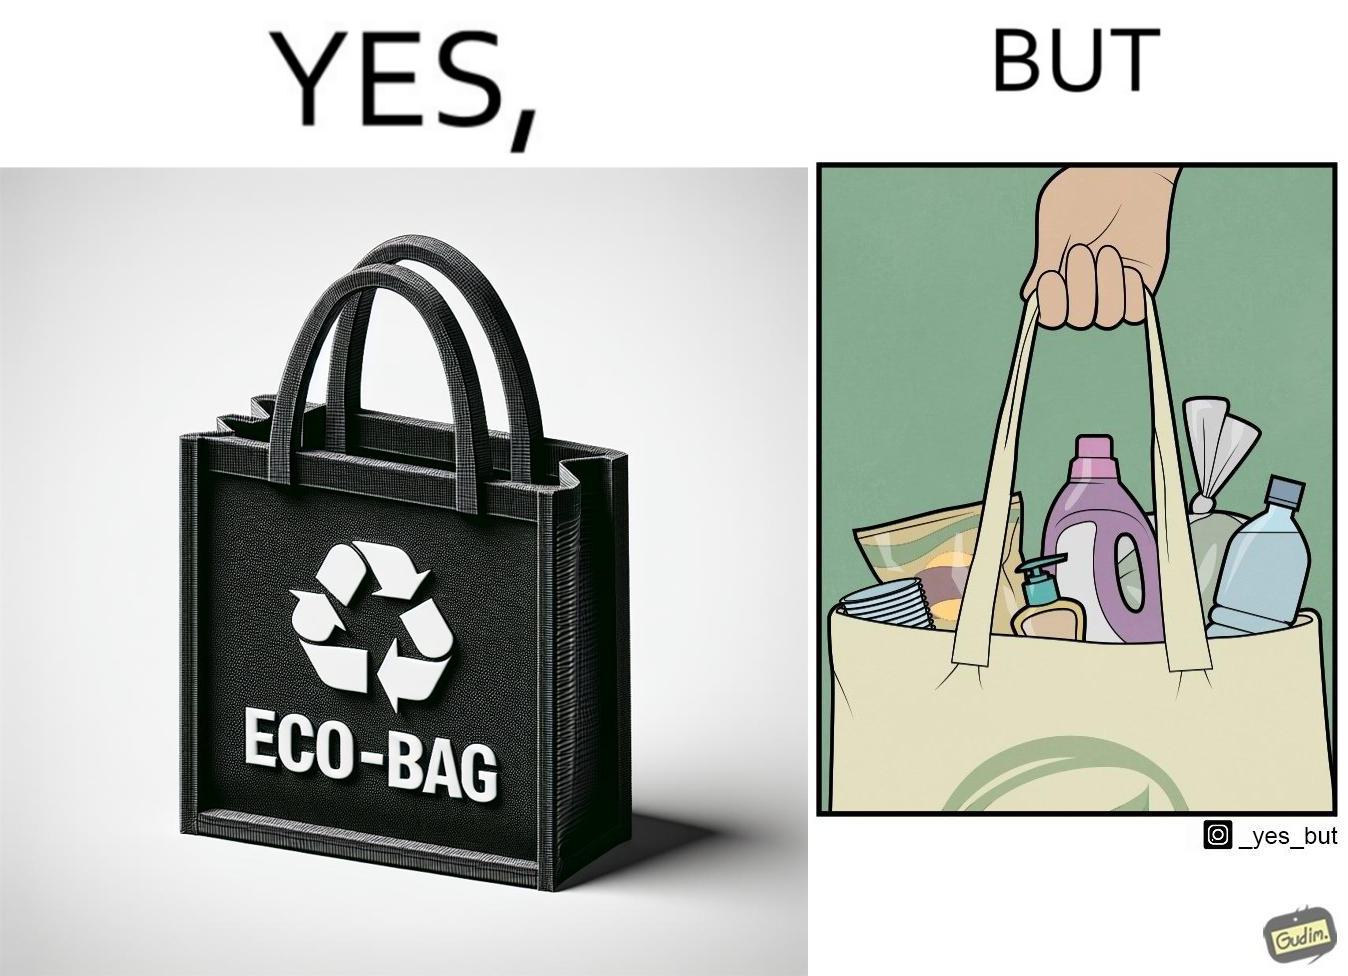Is this a satirical image? Yes, this image is satirical. 